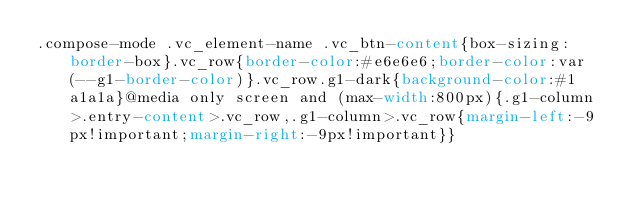Convert code to text. <code><loc_0><loc_0><loc_500><loc_500><_CSS_>.compose-mode .vc_element-name .vc_btn-content{box-sizing:border-box}.vc_row{border-color:#e6e6e6;border-color:var(--g1-border-color)}.vc_row.g1-dark{background-color:#1a1a1a}@media only screen and (max-width:800px){.g1-column>.entry-content>.vc_row,.g1-column>.vc_row{margin-left:-9px!important;margin-right:-9px!important}}</code> 